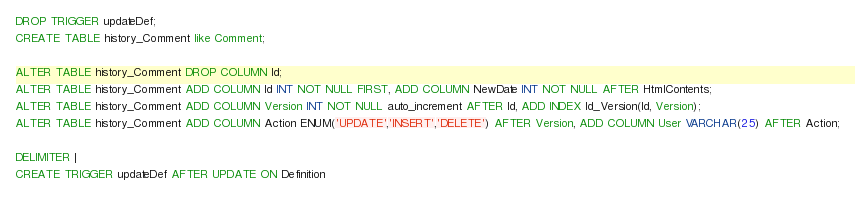Convert code to text. <code><loc_0><loc_0><loc_500><loc_500><_SQL_>DROP TRIGGER updateDef;
CREATE TABLE history_Comment like Comment;

ALTER TABLE history_Comment DROP COLUMN Id;
ALTER TABLE history_Comment ADD COLUMN Id INT NOT NULL FIRST, ADD COLUMN NewDate INT NOT NULL AFTER HtmlContents;
ALTER TABLE history_Comment ADD COLUMN Version INT NOT NULL auto_increment AFTER Id, ADD INDEX Id_Version(Id, Version);
ALTER TABLE history_Comment ADD COLUMN Action ENUM('UPDATE','INSERT','DELETE') AFTER Version, ADD COLUMN User VARCHAR(25) AFTER Action;

DELIMITER |
CREATE TRIGGER updateDef AFTER UPDATE ON Definition</code> 